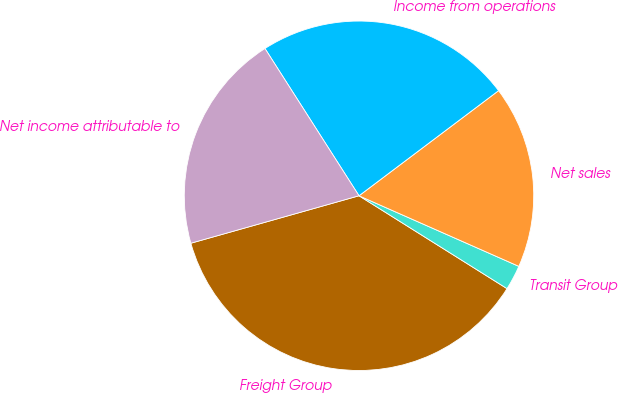Convert chart to OTSL. <chart><loc_0><loc_0><loc_500><loc_500><pie_chart><fcel>Freight Group<fcel>Transit Group<fcel>Net sales<fcel>Income from operations<fcel>Net income attributable to<nl><fcel>36.7%<fcel>2.3%<fcel>16.89%<fcel>23.77%<fcel>20.33%<nl></chart> 